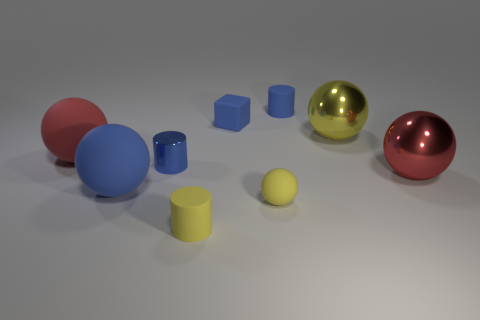The red rubber thing is what size?
Keep it short and to the point. Large. How many rubber objects are the same size as the blue block?
Your answer should be compact. 3. Are there fewer big shiny balls behind the blue metal thing than small blue objects that are to the left of the tiny blue rubber cylinder?
Your response must be concise. Yes. There is a cylinder in front of the blue metallic thing left of the cylinder on the right side of the yellow cylinder; how big is it?
Provide a succinct answer. Small. What size is the matte object that is behind the large yellow shiny thing and left of the yellow matte sphere?
Keep it short and to the point. Small. The blue matte thing that is in front of the shiny sphere left of the red metallic ball is what shape?
Provide a short and direct response. Sphere. Are there any other things of the same color as the tiny matte block?
Provide a short and direct response. Yes. What shape is the blue thing on the left side of the small metal cylinder?
Offer a terse response. Sphere. The thing that is both in front of the large blue thing and behind the tiny yellow rubber cylinder has what shape?
Provide a short and direct response. Sphere. What number of blue things are either tiny cylinders or small blocks?
Make the answer very short. 3. 